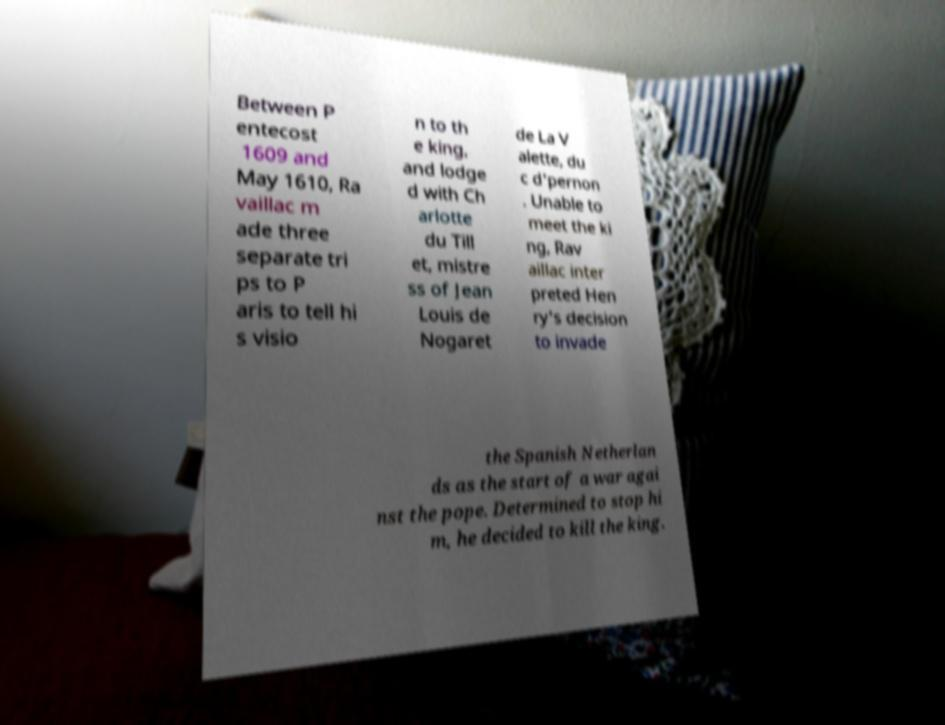There's text embedded in this image that I need extracted. Can you transcribe it verbatim? Between P entecost 1609 and May 1610, Ra vaillac m ade three separate tri ps to P aris to tell hi s visio n to th e king, and lodge d with Ch arlotte du Till et, mistre ss of Jean Louis de Nogaret de La V alette, du c d'pernon . Unable to meet the ki ng, Rav aillac inter preted Hen ry's decision to invade the Spanish Netherlan ds as the start of a war agai nst the pope. Determined to stop hi m, he decided to kill the king. 